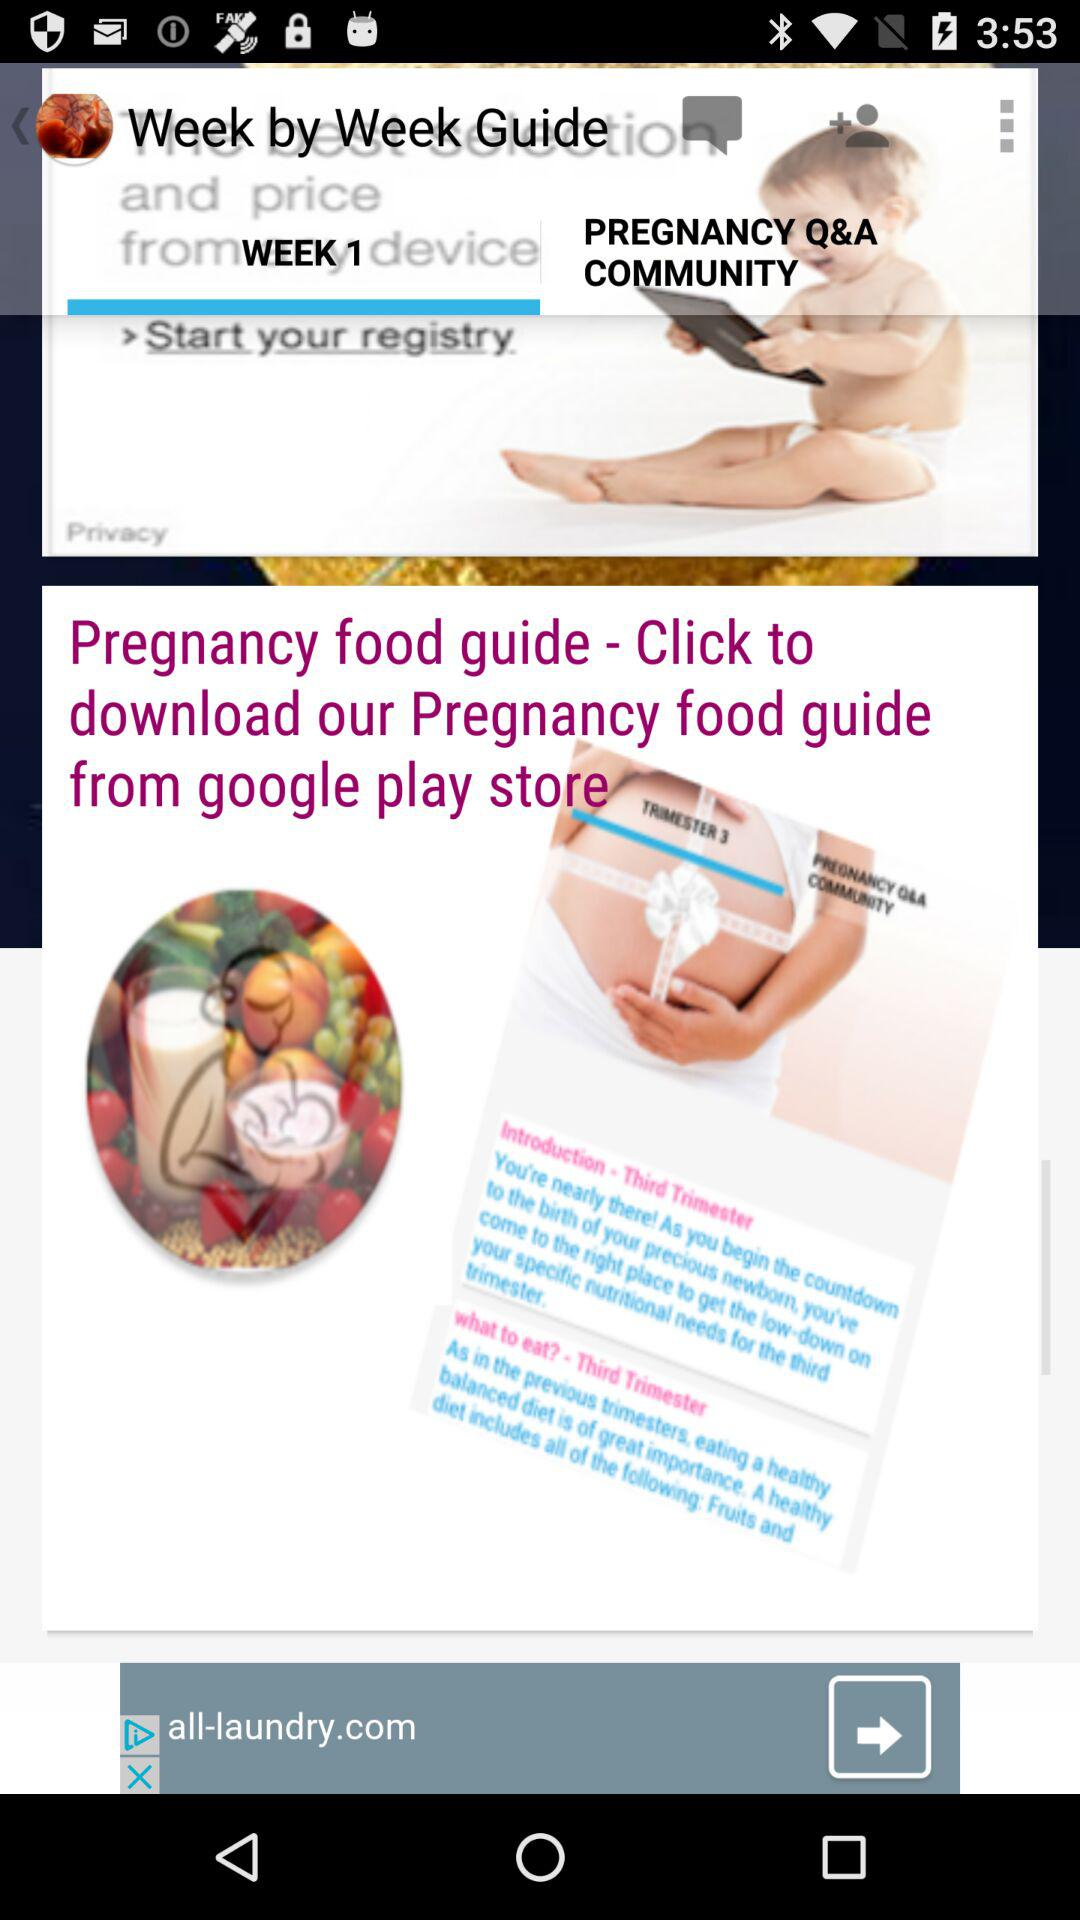What is the week number? The week number is 1. 